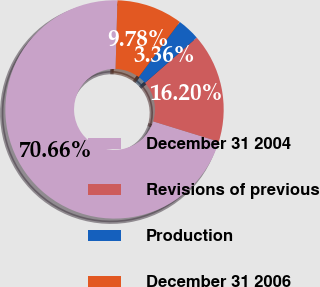<chart> <loc_0><loc_0><loc_500><loc_500><pie_chart><fcel>December 31 2004<fcel>Revisions of previous<fcel>Production<fcel>December 31 2006<nl><fcel>70.66%<fcel>16.2%<fcel>3.36%<fcel>9.78%<nl></chart> 